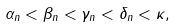<formula> <loc_0><loc_0><loc_500><loc_500>\alpha _ { n } < \beta _ { n } < \gamma _ { n } < \delta _ { n } < \kappa ,</formula> 